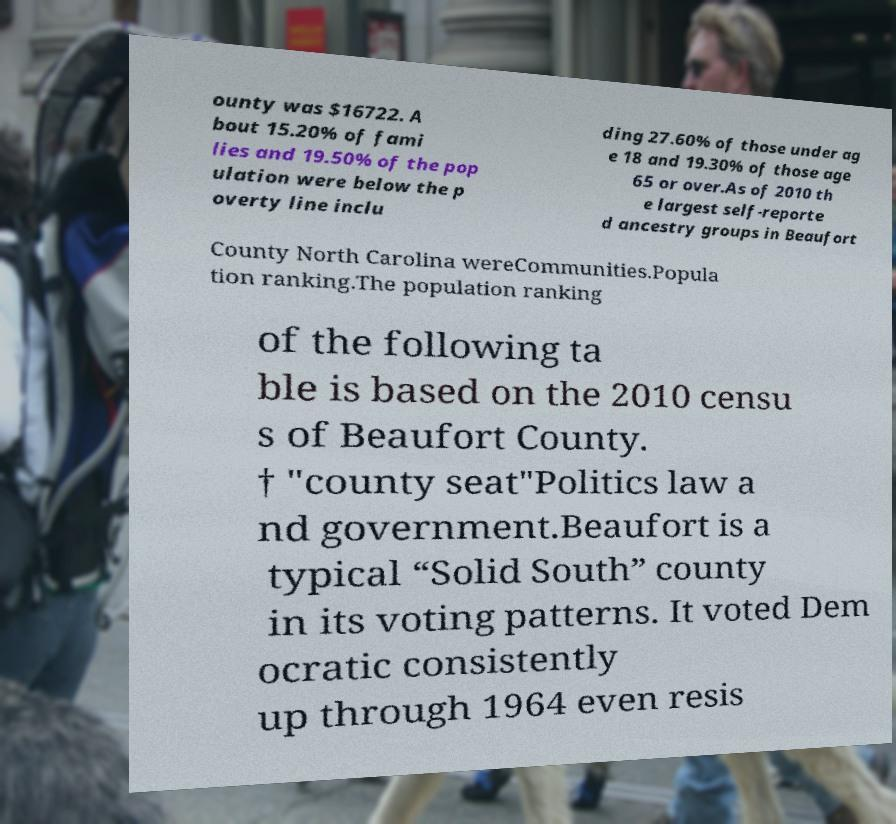Can you read and provide the text displayed in the image?This photo seems to have some interesting text. Can you extract and type it out for me? ounty was $16722. A bout 15.20% of fami lies and 19.50% of the pop ulation were below the p overty line inclu ding 27.60% of those under ag e 18 and 19.30% of those age 65 or over.As of 2010 th e largest self-reporte d ancestry groups in Beaufort County North Carolina wereCommunities.Popula tion ranking.The population ranking of the following ta ble is based on the 2010 censu s of Beaufort County. † "county seat"Politics law a nd government.Beaufort is a typical “Solid South” county in its voting patterns. It voted Dem ocratic consistently up through 1964 even resis 